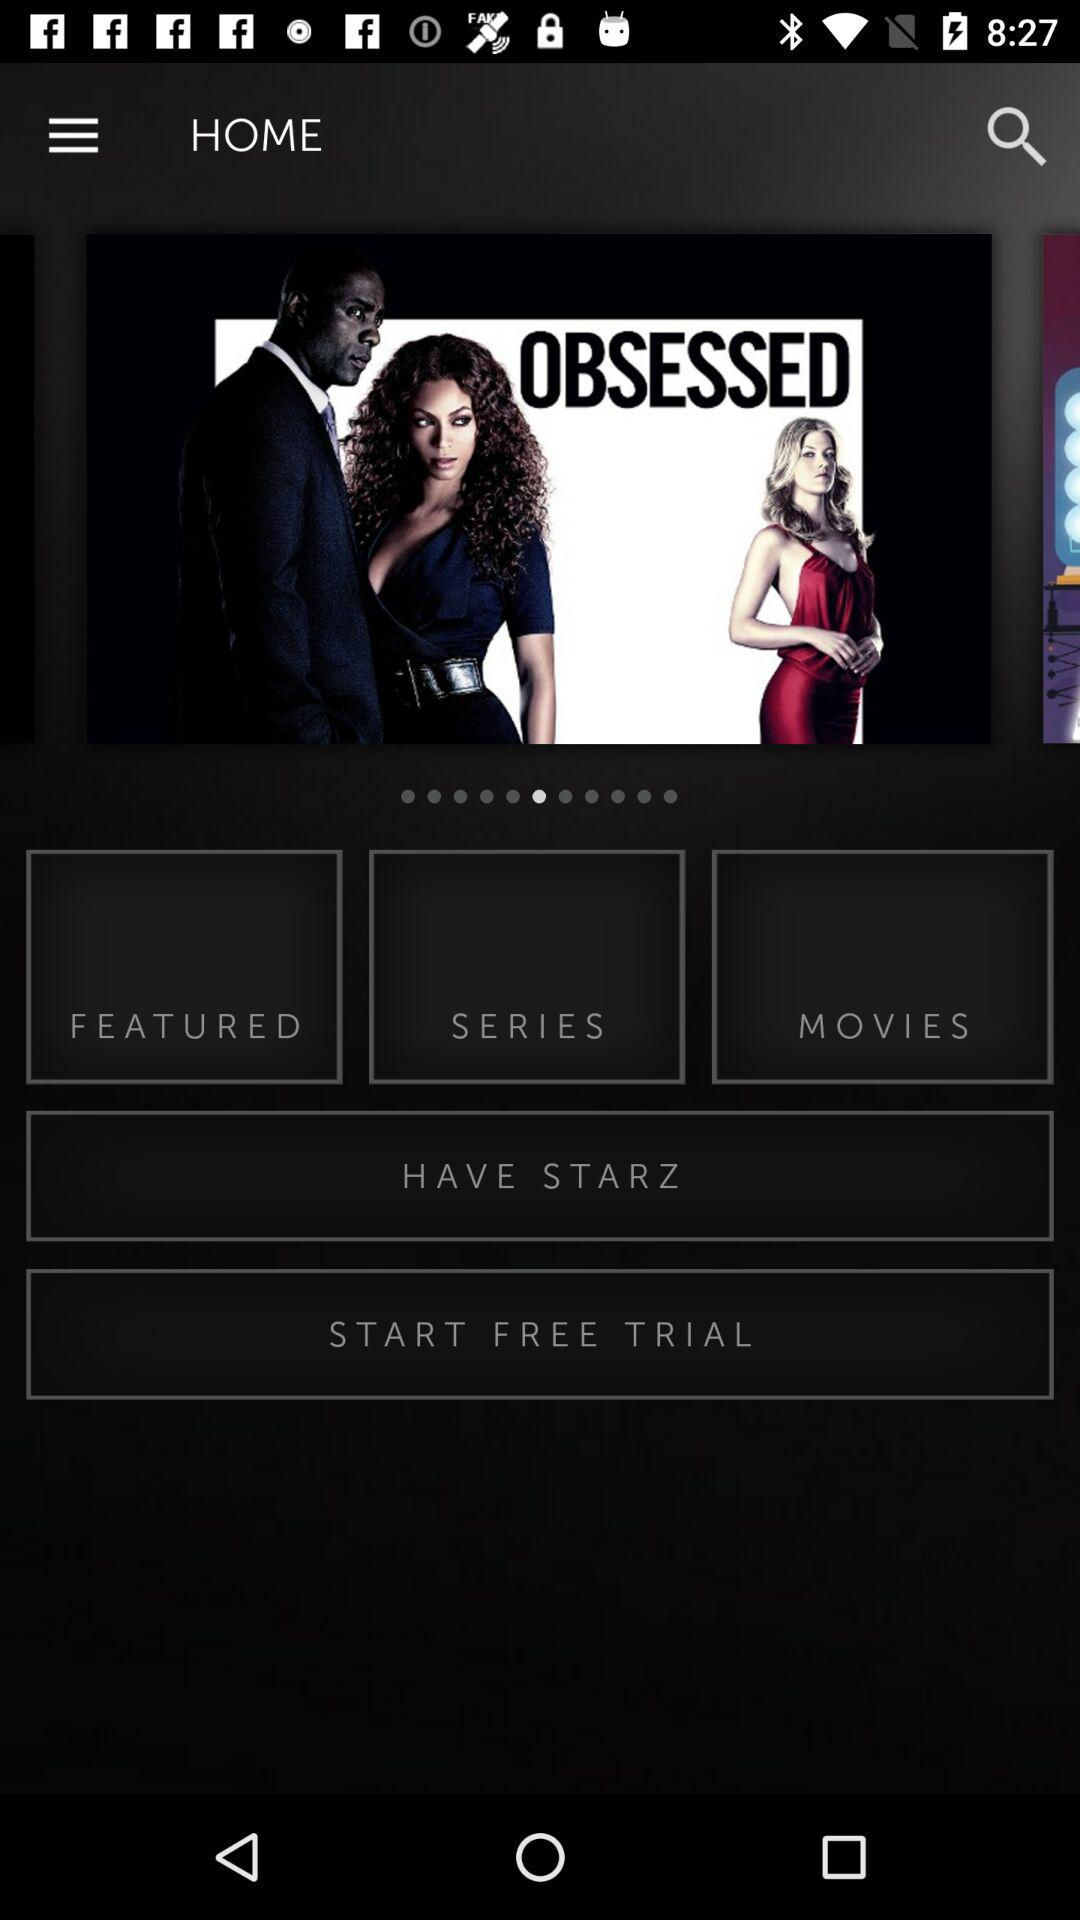What is the show name? The show name is "Obsessed". 